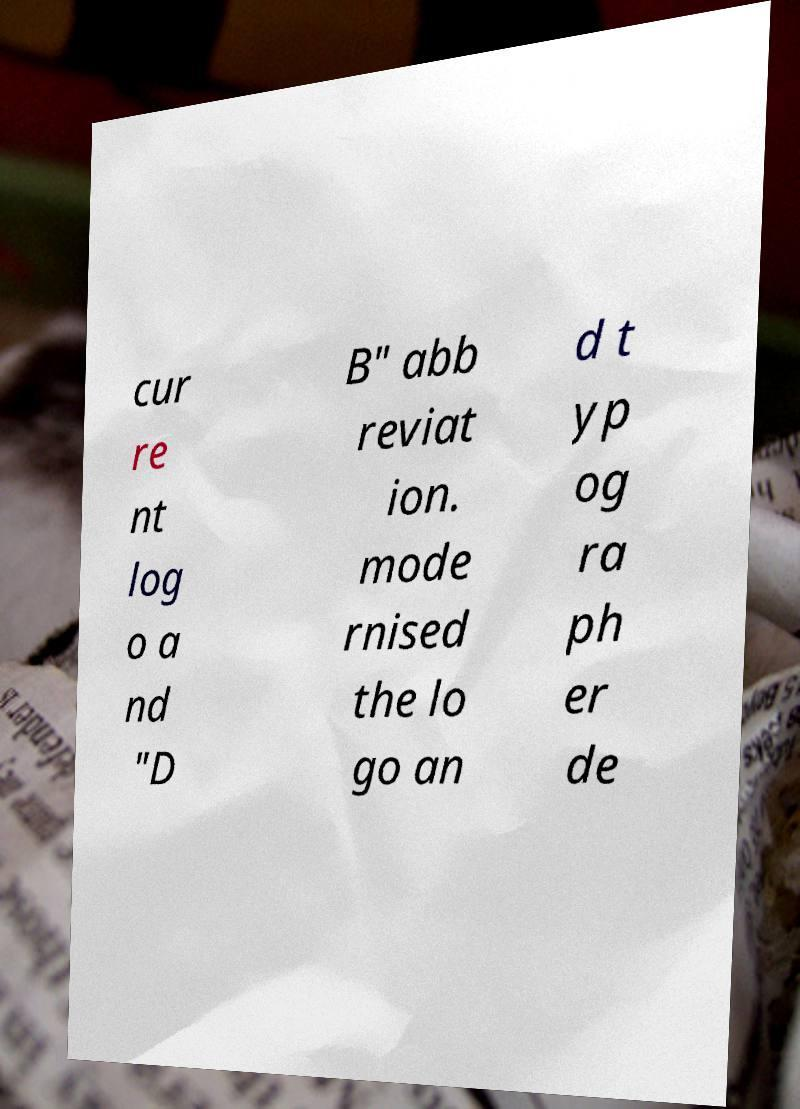What messages or text are displayed in this image? I need them in a readable, typed format. cur re nt log o a nd "D B" abb reviat ion. mode rnised the lo go an d t yp og ra ph er de 